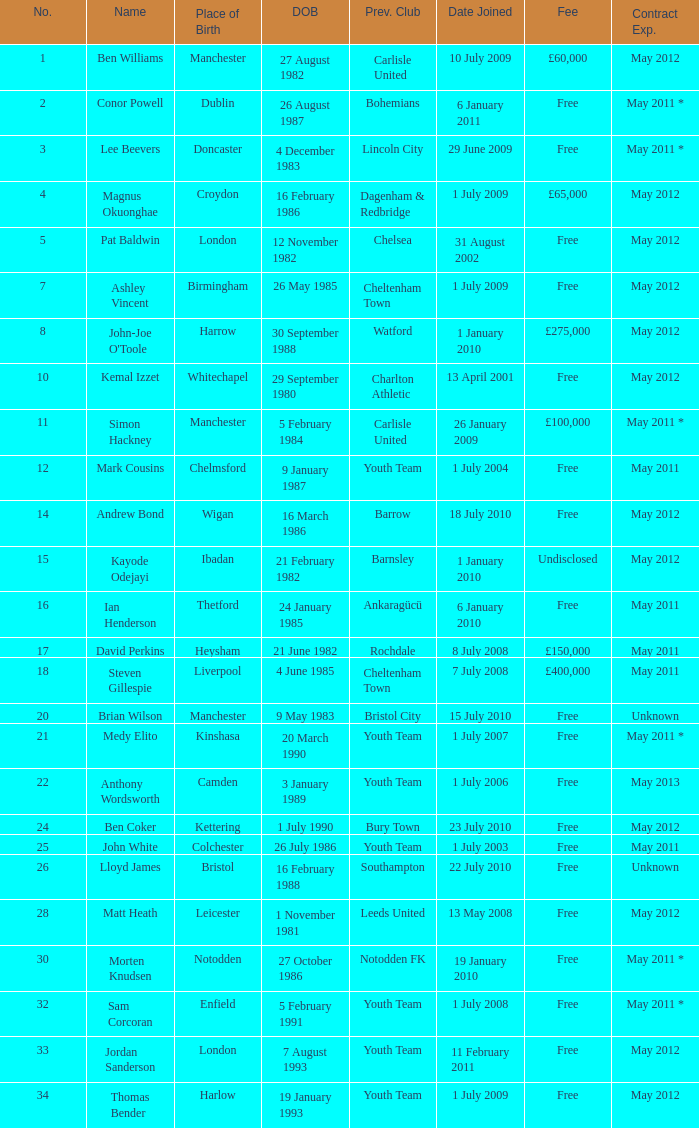For the ben williams name what was the previous club Carlisle United. 